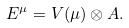<formula> <loc_0><loc_0><loc_500><loc_500>E ^ { \mu } = V ( \mu ) \otimes A .</formula> 